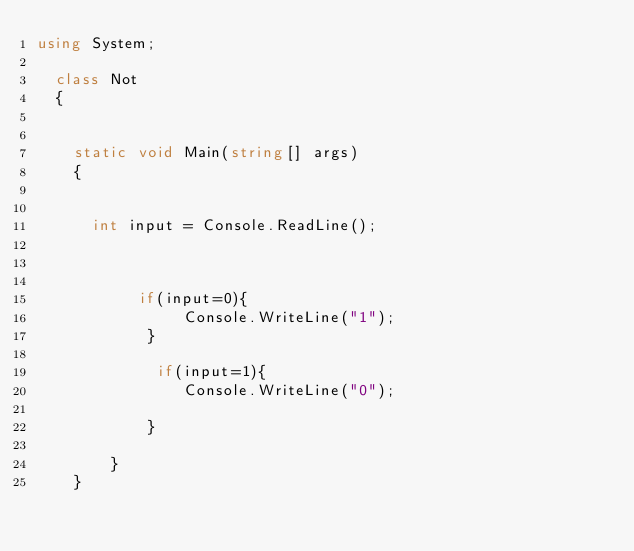Convert code to text. <code><loc_0><loc_0><loc_500><loc_500><_C#_>using System;
 
	class Not
	{

 
		static void Main(string[] args)
		{
			
        
			int input = Console.ReadLine();

            

           if(input=0){
                Console.WriteLine("1");
            }

             if(input=1){
                Console.WriteLine("0");

            }

        }
    }
    
</code> 